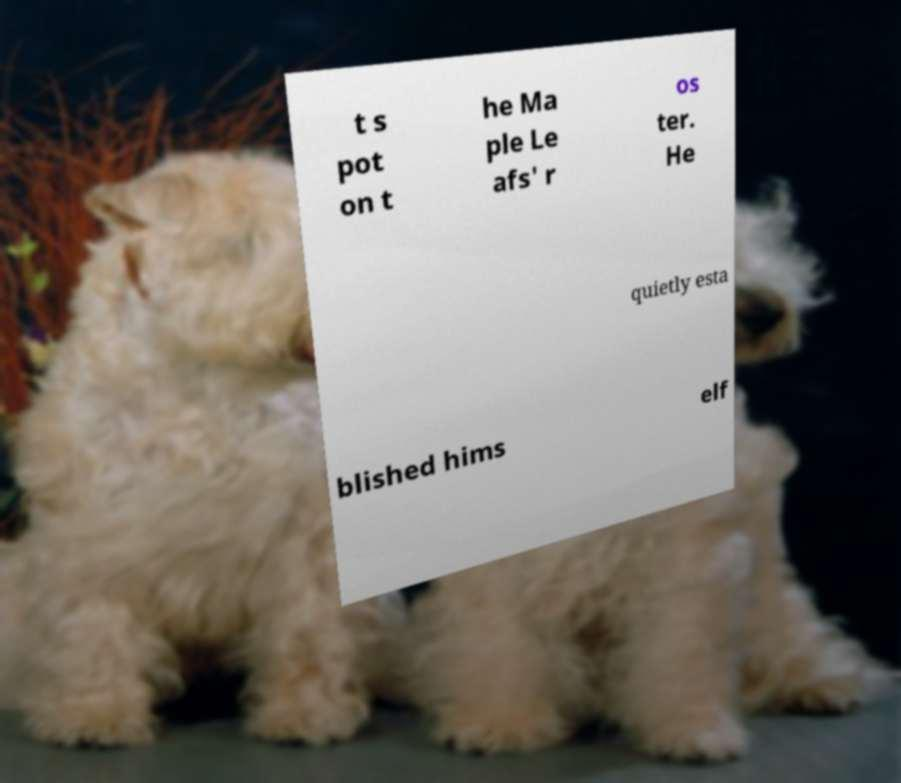Can you accurately transcribe the text from the provided image for me? t s pot on t he Ma ple Le afs' r os ter. He quietly esta blished hims elf 